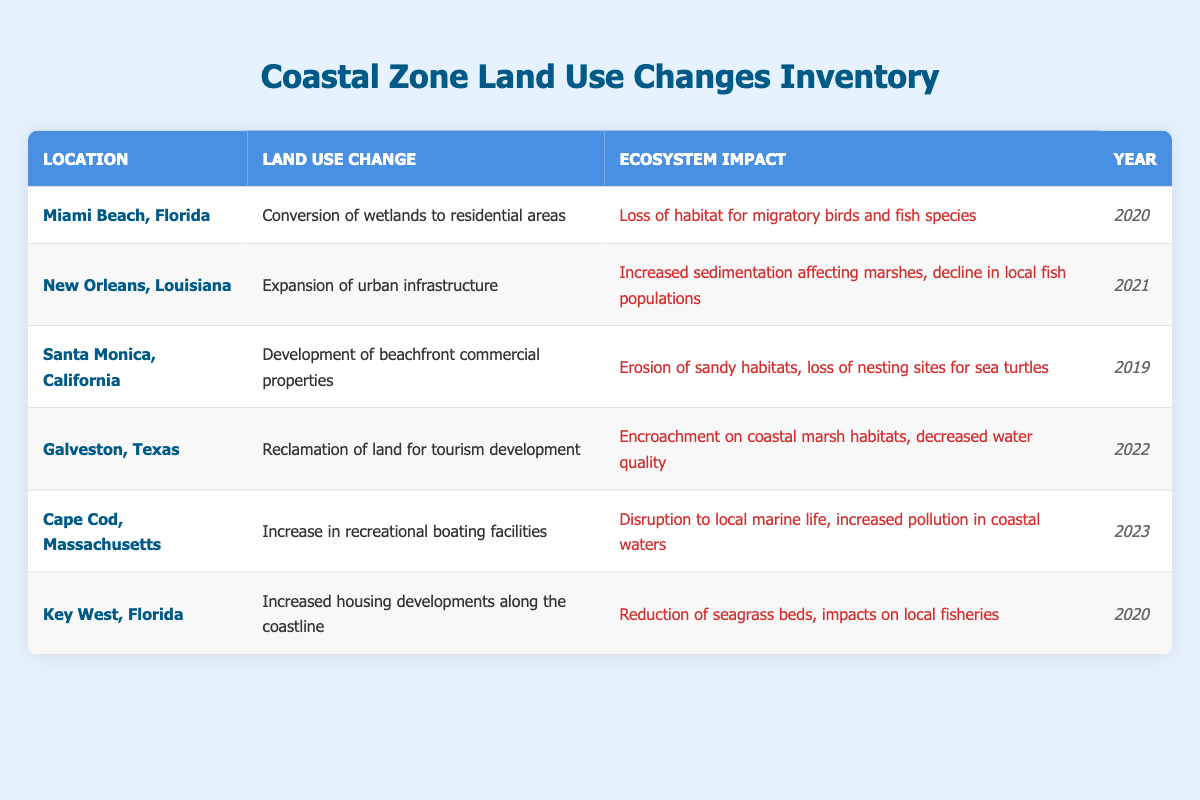What land use change occurred in Miami Beach, Florida? The table lists "Conversion of wetlands to residential areas" under the column for land use change associated with Miami Beach, Florida.
Answer: Conversion of wetlands to residential areas Which ecosystem impact is reported for the land use change in Santa Monica, California? The impact listed for Santa Monica, California, is "Erosion of sandy habitats, loss of nesting sites for sea turtles," as detailed in the ecosystem impact column.
Answer: Erosion of sandy habitats, loss of nesting sites for sea turtles How many locations mentioned land use changes in the year 2020? The table indicates two locations with land use changes in 2020: Miami Beach, Florida, and Key West, Florida; thus, there are two entries for that year.
Answer: 2 Is the ecosystem impact of increased housing developments in Key West, Florida, associated with a reduction of seagrass beds? According to the table, the ecosystem impact listed for Key West, Florida, is "Reduction of seagrass beds, impacts on local fisheries," confirming that this is true.
Answer: Yes What is the combined number of ecosystem impacts reported in 2021 and 2023? The table shows one ecosystem impact for New Orleans in 2021 and one for Cape Cod in 2023. Summing these gives a total of 2 distinct impacts across those years.
Answer: 2 What are the ecosystem impacts of land reclamation for tourism development in Galveston, Texas? The table specifies that the ecosystem impacts for Galveston, Texas, are "Encroachment on coastal marsh habitats, decreased water quality," providing clear details on the resulting effects of such land use changes.
Answer: Encroachment on coastal marsh habitats, decreased water quality Does the table indicate that increased recreational boating facilities are disrupting local marine life? Yes, the table explicitly states that the increase in recreational boating facilities in Cape Cod, Massachusetts, leads to "Disruption to local marine life," validating that this fact is true.
Answer: Yes How many land use changes are associated with a decline in local fish populations? The impacts listed for New Orleans, Louisiana, state "Increased sedimentation affecting marshes, decline in local fish populations," indicating only one land use change in the table directly connects to this decline. Hence, there is one such change.
Answer: 1 